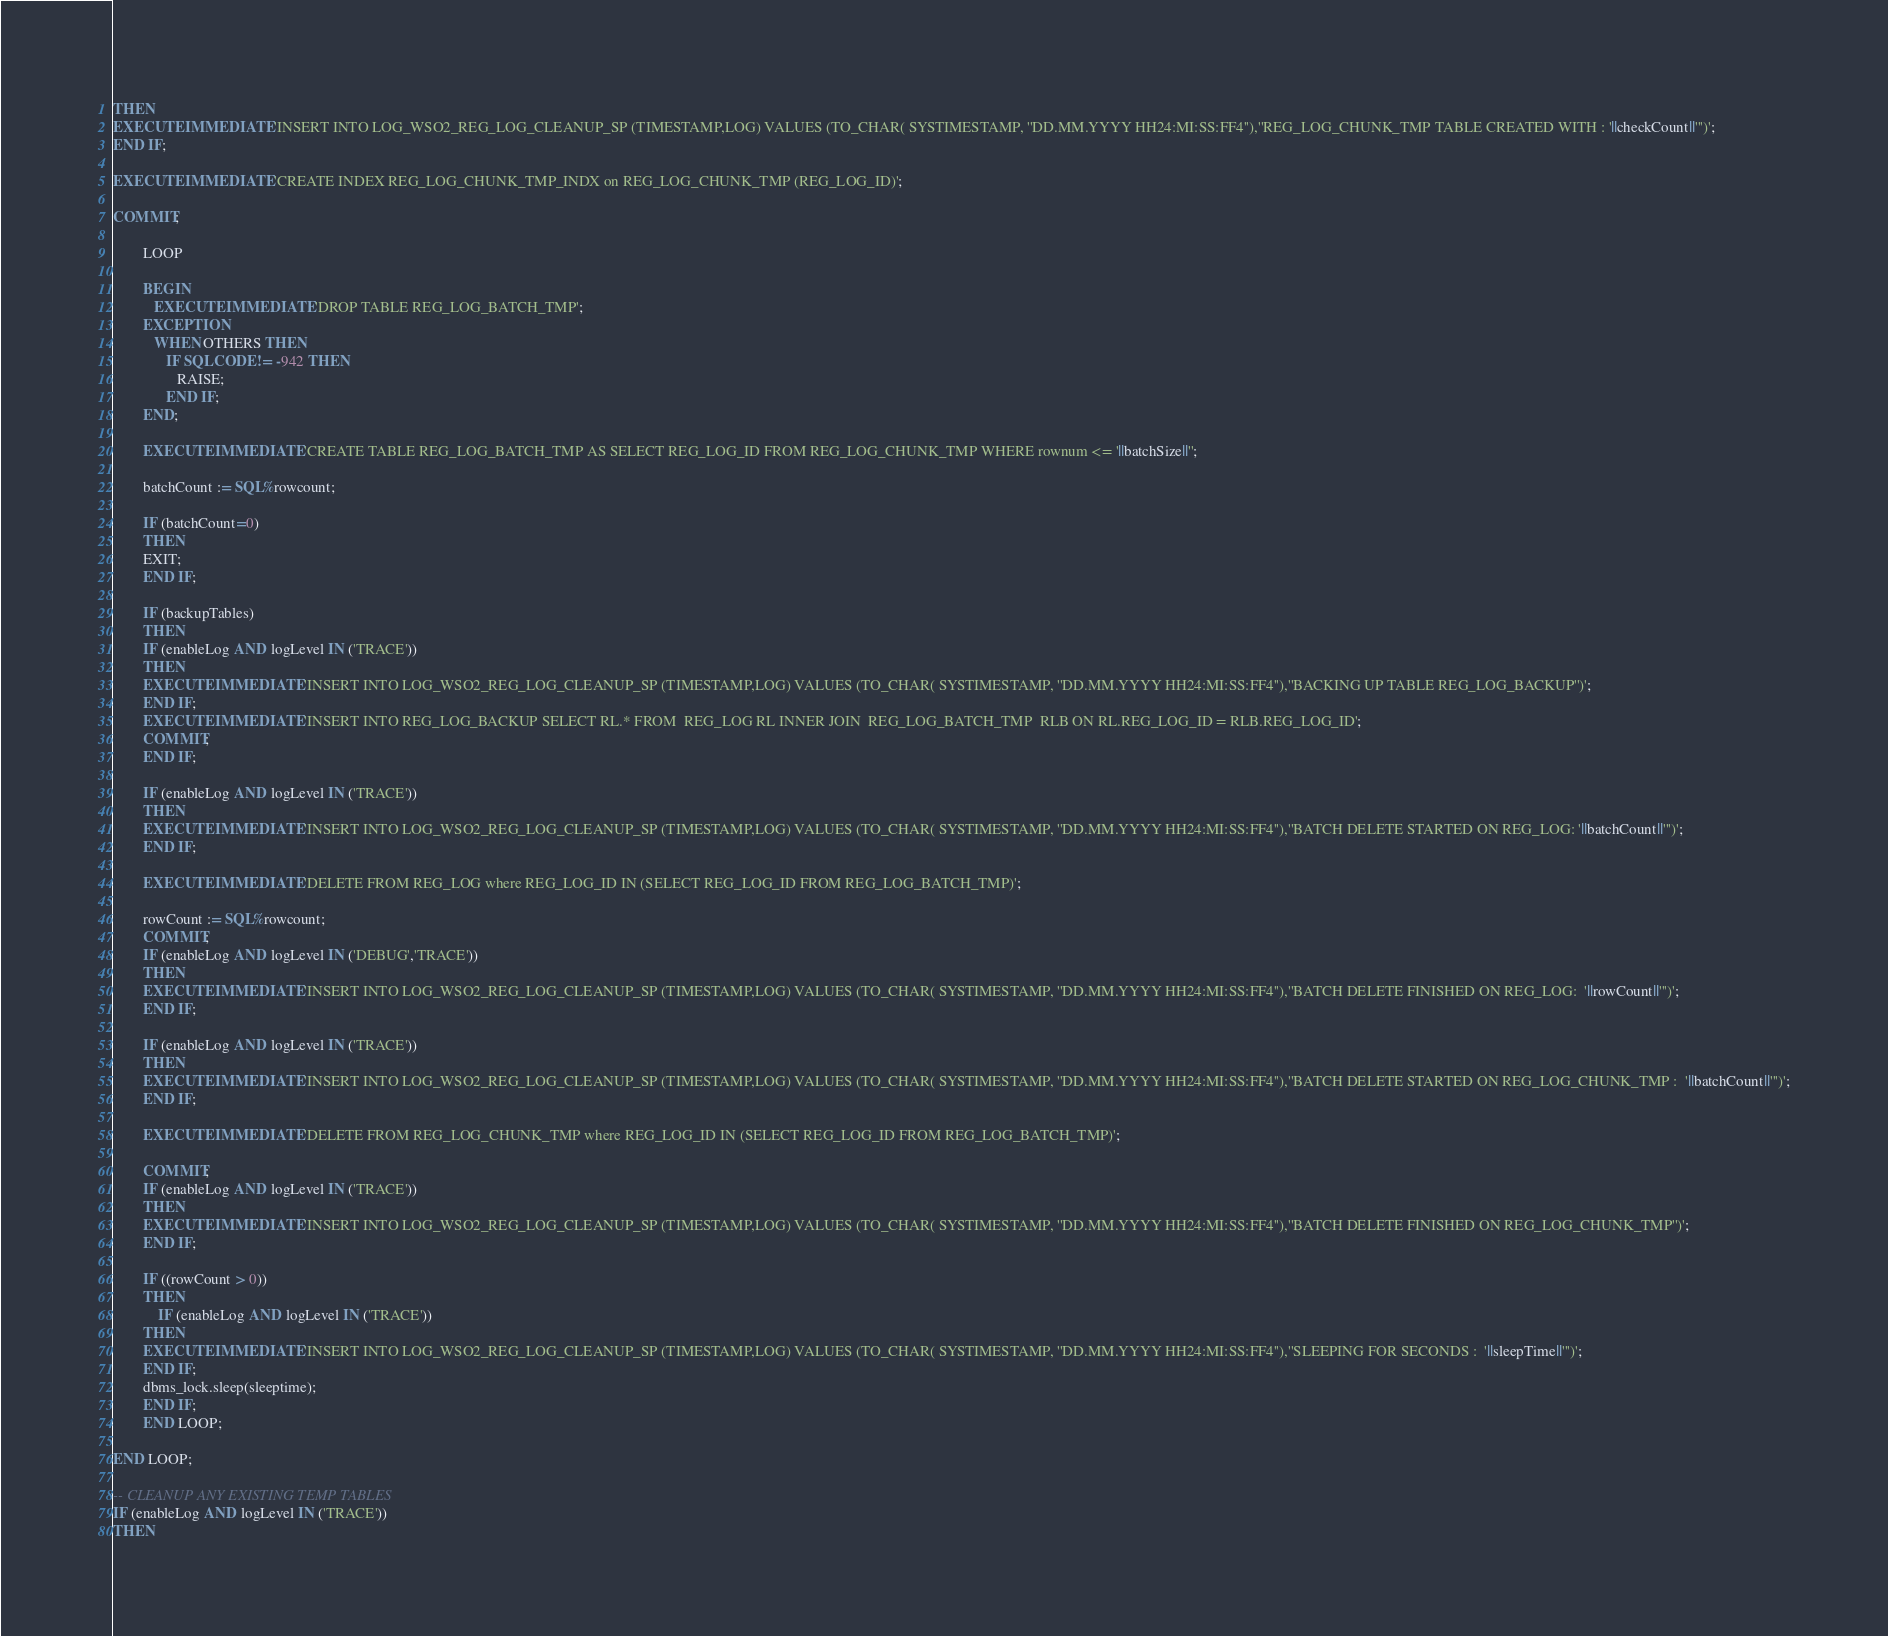Convert code to text. <code><loc_0><loc_0><loc_500><loc_500><_SQL_>THEN
EXECUTE IMMEDIATE 'INSERT INTO LOG_WSO2_REG_LOG_CLEANUP_SP (TIMESTAMP,LOG) VALUES (TO_CHAR( SYSTIMESTAMP, ''DD.MM.YYYY HH24:MI:SS:FF4''),''REG_LOG_CHUNK_TMP TABLE CREATED WITH : '||checkCount||''')';
END IF;

EXECUTE IMMEDIATE 'CREATE INDEX REG_LOG_CHUNK_TMP_INDX on REG_LOG_CHUNK_TMP (REG_LOG_ID)';

COMMIT;

        LOOP

        BEGIN
           EXECUTE IMMEDIATE 'DROP TABLE REG_LOG_BATCH_TMP';
        EXCEPTION
           WHEN OTHERS THEN
              IF SQLCODE != -942 THEN
                 RAISE;
              END IF;
        END;

        EXECUTE IMMEDIATE 'CREATE TABLE REG_LOG_BATCH_TMP AS SELECT REG_LOG_ID FROM REG_LOG_CHUNK_TMP WHERE rownum <= '||batchSize||'';

        batchCount := SQL%rowcount;

		IF (batchCount=0)
        THEN
        EXIT;
        END IF;

        IF (backupTables)
        THEN
        IF (enableLog AND logLevel IN ('TRACE'))
        THEN
        EXECUTE IMMEDIATE 'INSERT INTO LOG_WSO2_REG_LOG_CLEANUP_SP (TIMESTAMP,LOG) VALUES (TO_CHAR( SYSTIMESTAMP, ''DD.MM.YYYY HH24:MI:SS:FF4''),''BACKING UP TABLE REG_LOG_BACKUP'')';
        END IF;
        EXECUTE IMMEDIATE 'INSERT INTO REG_LOG_BACKUP SELECT RL.* FROM  REG_LOG RL INNER JOIN  REG_LOG_BATCH_TMP  RLB ON RL.REG_LOG_ID = RLB.REG_LOG_ID';
        COMMIT;
        END IF;

        IF (enableLog AND logLevel IN ('TRACE'))
        THEN
        EXECUTE IMMEDIATE 'INSERT INTO LOG_WSO2_REG_LOG_CLEANUP_SP (TIMESTAMP,LOG) VALUES (TO_CHAR( SYSTIMESTAMP, ''DD.MM.YYYY HH24:MI:SS:FF4''),''BATCH DELETE STARTED ON REG_LOG: '||batchCount||''')';
        END IF;

        EXECUTE IMMEDIATE 'DELETE FROM REG_LOG where REG_LOG_ID IN (SELECT REG_LOG_ID FROM REG_LOG_BATCH_TMP)';

        rowCount := SQL%rowcount;
		COMMIT;
        IF (enableLog AND logLevel IN ('DEBUG','TRACE'))
        THEN
        EXECUTE IMMEDIATE 'INSERT INTO LOG_WSO2_REG_LOG_CLEANUP_SP (TIMESTAMP,LOG) VALUES (TO_CHAR( SYSTIMESTAMP, ''DD.MM.YYYY HH24:MI:SS:FF4''),''BATCH DELETE FINISHED ON REG_LOG:  '||rowCount||''')';
        END IF;

        IF (enableLog AND logLevel IN ('TRACE'))
        THEN
        EXECUTE IMMEDIATE 'INSERT INTO LOG_WSO2_REG_LOG_CLEANUP_SP (TIMESTAMP,LOG) VALUES (TO_CHAR( SYSTIMESTAMP, ''DD.MM.YYYY HH24:MI:SS:FF4''),''BATCH DELETE STARTED ON REG_LOG_CHUNK_TMP :  '||batchCount||''')';
        END IF;

        EXECUTE IMMEDIATE 'DELETE FROM REG_LOG_CHUNK_TMP where REG_LOG_ID IN (SELECT REG_LOG_ID FROM REG_LOG_BATCH_TMP)';

		COMMIT;
        IF (enableLog AND logLevel IN ('TRACE'))
        THEN
        EXECUTE IMMEDIATE 'INSERT INTO LOG_WSO2_REG_LOG_CLEANUP_SP (TIMESTAMP,LOG) VALUES (TO_CHAR( SYSTIMESTAMP, ''DD.MM.YYYY HH24:MI:SS:FF4''),''BATCH DELETE FINISHED ON REG_LOG_CHUNK_TMP'')';
        END IF;

        IF ((rowCount > 0))
        THEN
            IF (enableLog AND logLevel IN ('TRACE'))
        THEN
        EXECUTE IMMEDIATE 'INSERT INTO LOG_WSO2_REG_LOG_CLEANUP_SP (TIMESTAMP,LOG) VALUES (TO_CHAR( SYSTIMESTAMP, ''DD.MM.YYYY HH24:MI:SS:FF4''),''SLEEPING FOR SECONDS :  '||sleepTime||''')';
        END IF;
        dbms_lock.sleep(sleeptime);
        END IF;
        END LOOP;

END LOOP;

-- CLEANUP ANY EXISTING TEMP TABLES
IF (enableLog AND logLevel IN ('TRACE'))
THEN</code> 